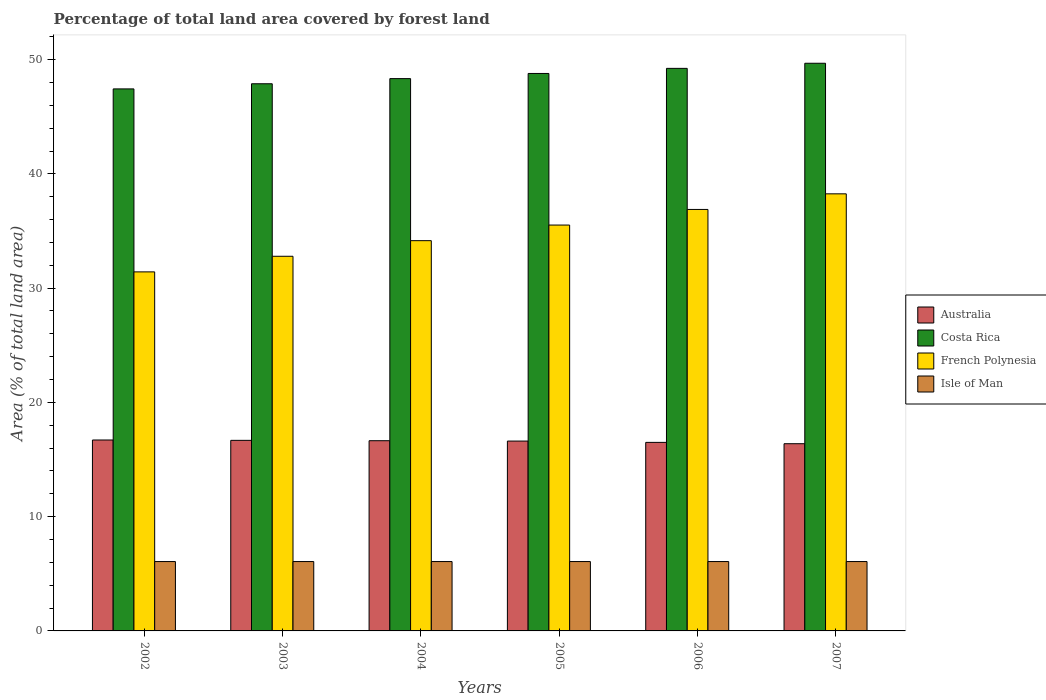How many different coloured bars are there?
Your response must be concise. 4. Are the number of bars on each tick of the X-axis equal?
Your answer should be very brief. Yes. How many bars are there on the 3rd tick from the left?
Provide a short and direct response. 4. How many bars are there on the 6th tick from the right?
Offer a very short reply. 4. What is the percentage of forest land in Isle of Man in 2003?
Your answer should be very brief. 6.07. Across all years, what is the maximum percentage of forest land in Australia?
Provide a succinct answer. 16.71. Across all years, what is the minimum percentage of forest land in French Polynesia?
Make the answer very short. 31.42. In which year was the percentage of forest land in Australia maximum?
Ensure brevity in your answer.  2002. In which year was the percentage of forest land in French Polynesia minimum?
Give a very brief answer. 2002. What is the total percentage of forest land in French Polynesia in the graph?
Offer a very short reply. 209.02. What is the difference between the percentage of forest land in Australia in 2003 and that in 2005?
Make the answer very short. 0.06. What is the difference between the percentage of forest land in Costa Rica in 2002 and the percentage of forest land in Australia in 2004?
Keep it short and to the point. 30.79. What is the average percentage of forest land in French Polynesia per year?
Provide a succinct answer. 34.84. In the year 2004, what is the difference between the percentage of forest land in Costa Rica and percentage of forest land in Isle of Man?
Offer a very short reply. 42.27. In how many years, is the percentage of forest land in Australia greater than 50 %?
Keep it short and to the point. 0. What is the ratio of the percentage of forest land in Costa Rica in 2004 to that in 2006?
Provide a short and direct response. 0.98. Is the percentage of forest land in Isle of Man in 2005 less than that in 2006?
Make the answer very short. No. Is the difference between the percentage of forest land in Costa Rica in 2002 and 2006 greater than the difference between the percentage of forest land in Isle of Man in 2002 and 2006?
Your answer should be compact. No. What is the difference between the highest and the second highest percentage of forest land in Isle of Man?
Give a very brief answer. 0. What is the difference between the highest and the lowest percentage of forest land in Costa Rica?
Offer a terse response. 2.24. In how many years, is the percentage of forest land in Costa Rica greater than the average percentage of forest land in Costa Rica taken over all years?
Your answer should be compact. 3. Is the sum of the percentage of forest land in French Polynesia in 2005 and 2007 greater than the maximum percentage of forest land in Isle of Man across all years?
Ensure brevity in your answer.  Yes. What does the 2nd bar from the left in 2003 represents?
Your response must be concise. Costa Rica. What does the 2nd bar from the right in 2004 represents?
Keep it short and to the point. French Polynesia. Is it the case that in every year, the sum of the percentage of forest land in French Polynesia and percentage of forest land in Costa Rica is greater than the percentage of forest land in Australia?
Offer a terse response. Yes. Where does the legend appear in the graph?
Provide a succinct answer. Center right. What is the title of the graph?
Provide a succinct answer. Percentage of total land area covered by forest land. Does "Afghanistan" appear as one of the legend labels in the graph?
Offer a terse response. No. What is the label or title of the X-axis?
Give a very brief answer. Years. What is the label or title of the Y-axis?
Provide a short and direct response. Area (% of total land area). What is the Area (% of total land area) of Australia in 2002?
Your answer should be compact. 16.71. What is the Area (% of total land area) of Costa Rica in 2002?
Keep it short and to the point. 47.43. What is the Area (% of total land area) of French Polynesia in 2002?
Your answer should be very brief. 31.42. What is the Area (% of total land area) of Isle of Man in 2002?
Your answer should be very brief. 6.07. What is the Area (% of total land area) in Australia in 2003?
Keep it short and to the point. 16.68. What is the Area (% of total land area) of Costa Rica in 2003?
Give a very brief answer. 47.88. What is the Area (% of total land area) in French Polynesia in 2003?
Keep it short and to the point. 32.79. What is the Area (% of total land area) in Isle of Man in 2003?
Make the answer very short. 6.07. What is the Area (% of total land area) of Australia in 2004?
Provide a short and direct response. 16.65. What is the Area (% of total land area) in Costa Rica in 2004?
Offer a very short reply. 48.34. What is the Area (% of total land area) of French Polynesia in 2004?
Offer a very short reply. 34.15. What is the Area (% of total land area) in Isle of Man in 2004?
Your response must be concise. 6.07. What is the Area (% of total land area) of Australia in 2005?
Your answer should be compact. 16.61. What is the Area (% of total land area) of Costa Rica in 2005?
Give a very brief answer. 48.79. What is the Area (% of total land area) in French Polynesia in 2005?
Your answer should be very brief. 35.52. What is the Area (% of total land area) in Isle of Man in 2005?
Keep it short and to the point. 6.07. What is the Area (% of total land area) of Australia in 2006?
Your response must be concise. 16.5. What is the Area (% of total land area) of Costa Rica in 2006?
Keep it short and to the point. 49.23. What is the Area (% of total land area) of French Polynesia in 2006?
Give a very brief answer. 36.89. What is the Area (% of total land area) in Isle of Man in 2006?
Provide a short and direct response. 6.07. What is the Area (% of total land area) of Australia in 2007?
Your answer should be very brief. 16.38. What is the Area (% of total land area) of Costa Rica in 2007?
Ensure brevity in your answer.  49.68. What is the Area (% of total land area) in French Polynesia in 2007?
Keep it short and to the point. 38.25. What is the Area (% of total land area) in Isle of Man in 2007?
Provide a succinct answer. 6.07. Across all years, what is the maximum Area (% of total land area) in Australia?
Your answer should be very brief. 16.71. Across all years, what is the maximum Area (% of total land area) of Costa Rica?
Your answer should be very brief. 49.68. Across all years, what is the maximum Area (% of total land area) in French Polynesia?
Provide a short and direct response. 38.25. Across all years, what is the maximum Area (% of total land area) in Isle of Man?
Offer a terse response. 6.07. Across all years, what is the minimum Area (% of total land area) of Australia?
Ensure brevity in your answer.  16.38. Across all years, what is the minimum Area (% of total land area) in Costa Rica?
Keep it short and to the point. 47.43. Across all years, what is the minimum Area (% of total land area) in French Polynesia?
Your answer should be compact. 31.42. Across all years, what is the minimum Area (% of total land area) in Isle of Man?
Offer a very short reply. 6.07. What is the total Area (% of total land area) of Australia in the graph?
Provide a succinct answer. 99.53. What is the total Area (% of total land area) of Costa Rica in the graph?
Ensure brevity in your answer.  291.35. What is the total Area (% of total land area) of French Polynesia in the graph?
Keep it short and to the point. 209.02. What is the total Area (% of total land area) of Isle of Man in the graph?
Make the answer very short. 36.42. What is the difference between the Area (% of total land area) of Australia in 2002 and that in 2003?
Provide a short and direct response. 0.03. What is the difference between the Area (% of total land area) in Costa Rica in 2002 and that in 2003?
Your answer should be compact. -0.45. What is the difference between the Area (% of total land area) of French Polynesia in 2002 and that in 2003?
Provide a succinct answer. -1.37. What is the difference between the Area (% of total land area) in Isle of Man in 2002 and that in 2003?
Offer a very short reply. 0. What is the difference between the Area (% of total land area) in Australia in 2002 and that in 2004?
Provide a short and direct response. 0.06. What is the difference between the Area (% of total land area) of Costa Rica in 2002 and that in 2004?
Your answer should be very brief. -0.9. What is the difference between the Area (% of total land area) in French Polynesia in 2002 and that in 2004?
Your answer should be compact. -2.73. What is the difference between the Area (% of total land area) of Australia in 2002 and that in 2005?
Offer a very short reply. 0.09. What is the difference between the Area (% of total land area) in Costa Rica in 2002 and that in 2005?
Your answer should be very brief. -1.35. What is the difference between the Area (% of total land area) in French Polynesia in 2002 and that in 2005?
Give a very brief answer. -4.1. What is the difference between the Area (% of total land area) of Isle of Man in 2002 and that in 2005?
Provide a short and direct response. 0. What is the difference between the Area (% of total land area) of Australia in 2002 and that in 2006?
Provide a succinct answer. 0.21. What is the difference between the Area (% of total land area) of Costa Rica in 2002 and that in 2006?
Your response must be concise. -1.8. What is the difference between the Area (% of total land area) of French Polynesia in 2002 and that in 2006?
Your response must be concise. -5.46. What is the difference between the Area (% of total land area) in Isle of Man in 2002 and that in 2006?
Keep it short and to the point. 0. What is the difference between the Area (% of total land area) of Australia in 2002 and that in 2007?
Offer a terse response. 0.32. What is the difference between the Area (% of total land area) in Costa Rica in 2002 and that in 2007?
Ensure brevity in your answer.  -2.24. What is the difference between the Area (% of total land area) in French Polynesia in 2002 and that in 2007?
Keep it short and to the point. -6.83. What is the difference between the Area (% of total land area) in Australia in 2003 and that in 2004?
Offer a very short reply. 0.03. What is the difference between the Area (% of total land area) in Costa Rica in 2003 and that in 2004?
Provide a succinct answer. -0.45. What is the difference between the Area (% of total land area) in French Polynesia in 2003 and that in 2004?
Ensure brevity in your answer.  -1.37. What is the difference between the Area (% of total land area) of Isle of Man in 2003 and that in 2004?
Provide a succinct answer. 0. What is the difference between the Area (% of total land area) of Australia in 2003 and that in 2005?
Your answer should be very brief. 0.06. What is the difference between the Area (% of total land area) in Costa Rica in 2003 and that in 2005?
Your answer should be compact. -0.9. What is the difference between the Area (% of total land area) of French Polynesia in 2003 and that in 2005?
Make the answer very short. -2.73. What is the difference between the Area (% of total land area) of Isle of Man in 2003 and that in 2005?
Make the answer very short. 0. What is the difference between the Area (% of total land area) in Australia in 2003 and that in 2006?
Offer a very short reply. 0.18. What is the difference between the Area (% of total land area) of Costa Rica in 2003 and that in 2006?
Your response must be concise. -1.35. What is the difference between the Area (% of total land area) in French Polynesia in 2003 and that in 2006?
Offer a terse response. -4.1. What is the difference between the Area (% of total land area) in Australia in 2003 and that in 2007?
Your response must be concise. 0.29. What is the difference between the Area (% of total land area) of Costa Rica in 2003 and that in 2007?
Your answer should be compact. -1.79. What is the difference between the Area (% of total land area) in French Polynesia in 2003 and that in 2007?
Provide a short and direct response. -5.46. What is the difference between the Area (% of total land area) in Australia in 2004 and that in 2005?
Provide a short and direct response. 0.03. What is the difference between the Area (% of total land area) in Costa Rica in 2004 and that in 2005?
Provide a succinct answer. -0.45. What is the difference between the Area (% of total land area) of French Polynesia in 2004 and that in 2005?
Offer a very short reply. -1.37. What is the difference between the Area (% of total land area) in Isle of Man in 2004 and that in 2005?
Make the answer very short. 0. What is the difference between the Area (% of total land area) in Australia in 2004 and that in 2006?
Provide a short and direct response. 0.15. What is the difference between the Area (% of total land area) of Costa Rica in 2004 and that in 2006?
Keep it short and to the point. -0.9. What is the difference between the Area (% of total land area) in French Polynesia in 2004 and that in 2006?
Offer a terse response. -2.73. What is the difference between the Area (% of total land area) of Isle of Man in 2004 and that in 2006?
Ensure brevity in your answer.  0. What is the difference between the Area (% of total land area) in Australia in 2004 and that in 2007?
Give a very brief answer. 0.26. What is the difference between the Area (% of total land area) of Costa Rica in 2004 and that in 2007?
Offer a terse response. -1.34. What is the difference between the Area (% of total land area) in French Polynesia in 2004 and that in 2007?
Your answer should be very brief. -4.1. What is the difference between the Area (% of total land area) of Isle of Man in 2004 and that in 2007?
Keep it short and to the point. 0. What is the difference between the Area (% of total land area) in Australia in 2005 and that in 2006?
Offer a terse response. 0.12. What is the difference between the Area (% of total land area) of Costa Rica in 2005 and that in 2006?
Provide a short and direct response. -0.45. What is the difference between the Area (% of total land area) of French Polynesia in 2005 and that in 2006?
Offer a very short reply. -1.37. What is the difference between the Area (% of total land area) in Isle of Man in 2005 and that in 2006?
Ensure brevity in your answer.  0. What is the difference between the Area (% of total land area) in Australia in 2005 and that in 2007?
Offer a very short reply. 0.23. What is the difference between the Area (% of total land area) in Costa Rica in 2005 and that in 2007?
Give a very brief answer. -0.89. What is the difference between the Area (% of total land area) in French Polynesia in 2005 and that in 2007?
Provide a short and direct response. -2.73. What is the difference between the Area (% of total land area) in Australia in 2006 and that in 2007?
Make the answer very short. 0.12. What is the difference between the Area (% of total land area) of Costa Rica in 2006 and that in 2007?
Offer a very short reply. -0.45. What is the difference between the Area (% of total land area) in French Polynesia in 2006 and that in 2007?
Your answer should be compact. -1.37. What is the difference between the Area (% of total land area) of Isle of Man in 2006 and that in 2007?
Offer a very short reply. 0. What is the difference between the Area (% of total land area) in Australia in 2002 and the Area (% of total land area) in Costa Rica in 2003?
Offer a very short reply. -31.18. What is the difference between the Area (% of total land area) of Australia in 2002 and the Area (% of total land area) of French Polynesia in 2003?
Offer a terse response. -16.08. What is the difference between the Area (% of total land area) of Australia in 2002 and the Area (% of total land area) of Isle of Man in 2003?
Provide a succinct answer. 10.64. What is the difference between the Area (% of total land area) of Costa Rica in 2002 and the Area (% of total land area) of French Polynesia in 2003?
Your response must be concise. 14.65. What is the difference between the Area (% of total land area) of Costa Rica in 2002 and the Area (% of total land area) of Isle of Man in 2003?
Provide a succinct answer. 41.36. What is the difference between the Area (% of total land area) in French Polynesia in 2002 and the Area (% of total land area) in Isle of Man in 2003?
Offer a very short reply. 25.35. What is the difference between the Area (% of total land area) of Australia in 2002 and the Area (% of total land area) of Costa Rica in 2004?
Your response must be concise. -31.63. What is the difference between the Area (% of total land area) in Australia in 2002 and the Area (% of total land area) in French Polynesia in 2004?
Make the answer very short. -17.44. What is the difference between the Area (% of total land area) of Australia in 2002 and the Area (% of total land area) of Isle of Man in 2004?
Make the answer very short. 10.64. What is the difference between the Area (% of total land area) of Costa Rica in 2002 and the Area (% of total land area) of French Polynesia in 2004?
Make the answer very short. 13.28. What is the difference between the Area (% of total land area) in Costa Rica in 2002 and the Area (% of total land area) in Isle of Man in 2004?
Your response must be concise. 41.36. What is the difference between the Area (% of total land area) of French Polynesia in 2002 and the Area (% of total land area) of Isle of Man in 2004?
Keep it short and to the point. 25.35. What is the difference between the Area (% of total land area) in Australia in 2002 and the Area (% of total land area) in Costa Rica in 2005?
Make the answer very short. -32.08. What is the difference between the Area (% of total land area) in Australia in 2002 and the Area (% of total land area) in French Polynesia in 2005?
Your response must be concise. -18.81. What is the difference between the Area (% of total land area) in Australia in 2002 and the Area (% of total land area) in Isle of Man in 2005?
Provide a succinct answer. 10.64. What is the difference between the Area (% of total land area) in Costa Rica in 2002 and the Area (% of total land area) in French Polynesia in 2005?
Offer a very short reply. 11.92. What is the difference between the Area (% of total land area) in Costa Rica in 2002 and the Area (% of total land area) in Isle of Man in 2005?
Your answer should be compact. 41.36. What is the difference between the Area (% of total land area) of French Polynesia in 2002 and the Area (% of total land area) of Isle of Man in 2005?
Offer a very short reply. 25.35. What is the difference between the Area (% of total land area) in Australia in 2002 and the Area (% of total land area) in Costa Rica in 2006?
Make the answer very short. -32.52. What is the difference between the Area (% of total land area) of Australia in 2002 and the Area (% of total land area) of French Polynesia in 2006?
Your response must be concise. -20.18. What is the difference between the Area (% of total land area) of Australia in 2002 and the Area (% of total land area) of Isle of Man in 2006?
Offer a very short reply. 10.64. What is the difference between the Area (% of total land area) in Costa Rica in 2002 and the Area (% of total land area) in French Polynesia in 2006?
Ensure brevity in your answer.  10.55. What is the difference between the Area (% of total land area) of Costa Rica in 2002 and the Area (% of total land area) of Isle of Man in 2006?
Ensure brevity in your answer.  41.36. What is the difference between the Area (% of total land area) of French Polynesia in 2002 and the Area (% of total land area) of Isle of Man in 2006?
Make the answer very short. 25.35. What is the difference between the Area (% of total land area) in Australia in 2002 and the Area (% of total land area) in Costa Rica in 2007?
Give a very brief answer. -32.97. What is the difference between the Area (% of total land area) in Australia in 2002 and the Area (% of total land area) in French Polynesia in 2007?
Give a very brief answer. -21.54. What is the difference between the Area (% of total land area) in Australia in 2002 and the Area (% of total land area) in Isle of Man in 2007?
Your answer should be very brief. 10.64. What is the difference between the Area (% of total land area) of Costa Rica in 2002 and the Area (% of total land area) of French Polynesia in 2007?
Ensure brevity in your answer.  9.18. What is the difference between the Area (% of total land area) of Costa Rica in 2002 and the Area (% of total land area) of Isle of Man in 2007?
Your answer should be very brief. 41.36. What is the difference between the Area (% of total land area) of French Polynesia in 2002 and the Area (% of total land area) of Isle of Man in 2007?
Give a very brief answer. 25.35. What is the difference between the Area (% of total land area) in Australia in 2003 and the Area (% of total land area) in Costa Rica in 2004?
Your response must be concise. -31.66. What is the difference between the Area (% of total land area) in Australia in 2003 and the Area (% of total land area) in French Polynesia in 2004?
Offer a very short reply. -17.48. What is the difference between the Area (% of total land area) of Australia in 2003 and the Area (% of total land area) of Isle of Man in 2004?
Make the answer very short. 10.61. What is the difference between the Area (% of total land area) of Costa Rica in 2003 and the Area (% of total land area) of French Polynesia in 2004?
Your response must be concise. 13.73. What is the difference between the Area (% of total land area) of Costa Rica in 2003 and the Area (% of total land area) of Isle of Man in 2004?
Offer a terse response. 41.81. What is the difference between the Area (% of total land area) of French Polynesia in 2003 and the Area (% of total land area) of Isle of Man in 2004?
Your response must be concise. 26.72. What is the difference between the Area (% of total land area) of Australia in 2003 and the Area (% of total land area) of Costa Rica in 2005?
Ensure brevity in your answer.  -32.11. What is the difference between the Area (% of total land area) of Australia in 2003 and the Area (% of total land area) of French Polynesia in 2005?
Your response must be concise. -18.84. What is the difference between the Area (% of total land area) of Australia in 2003 and the Area (% of total land area) of Isle of Man in 2005?
Keep it short and to the point. 10.61. What is the difference between the Area (% of total land area) of Costa Rica in 2003 and the Area (% of total land area) of French Polynesia in 2005?
Offer a very short reply. 12.37. What is the difference between the Area (% of total land area) of Costa Rica in 2003 and the Area (% of total land area) of Isle of Man in 2005?
Provide a succinct answer. 41.81. What is the difference between the Area (% of total land area) of French Polynesia in 2003 and the Area (% of total land area) of Isle of Man in 2005?
Offer a terse response. 26.72. What is the difference between the Area (% of total land area) of Australia in 2003 and the Area (% of total land area) of Costa Rica in 2006?
Offer a terse response. -32.55. What is the difference between the Area (% of total land area) in Australia in 2003 and the Area (% of total land area) in French Polynesia in 2006?
Offer a terse response. -20.21. What is the difference between the Area (% of total land area) of Australia in 2003 and the Area (% of total land area) of Isle of Man in 2006?
Offer a very short reply. 10.61. What is the difference between the Area (% of total land area) in Costa Rica in 2003 and the Area (% of total land area) in French Polynesia in 2006?
Offer a terse response. 11. What is the difference between the Area (% of total land area) of Costa Rica in 2003 and the Area (% of total land area) of Isle of Man in 2006?
Ensure brevity in your answer.  41.81. What is the difference between the Area (% of total land area) of French Polynesia in 2003 and the Area (% of total land area) of Isle of Man in 2006?
Your answer should be very brief. 26.72. What is the difference between the Area (% of total land area) of Australia in 2003 and the Area (% of total land area) of Costa Rica in 2007?
Your answer should be very brief. -33. What is the difference between the Area (% of total land area) in Australia in 2003 and the Area (% of total land area) in French Polynesia in 2007?
Offer a terse response. -21.57. What is the difference between the Area (% of total land area) of Australia in 2003 and the Area (% of total land area) of Isle of Man in 2007?
Offer a very short reply. 10.61. What is the difference between the Area (% of total land area) of Costa Rica in 2003 and the Area (% of total land area) of French Polynesia in 2007?
Give a very brief answer. 9.63. What is the difference between the Area (% of total land area) in Costa Rica in 2003 and the Area (% of total land area) in Isle of Man in 2007?
Ensure brevity in your answer.  41.81. What is the difference between the Area (% of total land area) of French Polynesia in 2003 and the Area (% of total land area) of Isle of Man in 2007?
Your answer should be compact. 26.72. What is the difference between the Area (% of total land area) in Australia in 2004 and the Area (% of total land area) in Costa Rica in 2005?
Keep it short and to the point. -32.14. What is the difference between the Area (% of total land area) in Australia in 2004 and the Area (% of total land area) in French Polynesia in 2005?
Your answer should be compact. -18.87. What is the difference between the Area (% of total land area) in Australia in 2004 and the Area (% of total land area) in Isle of Man in 2005?
Offer a very short reply. 10.58. What is the difference between the Area (% of total land area) in Costa Rica in 2004 and the Area (% of total land area) in French Polynesia in 2005?
Keep it short and to the point. 12.82. What is the difference between the Area (% of total land area) in Costa Rica in 2004 and the Area (% of total land area) in Isle of Man in 2005?
Provide a succinct answer. 42.27. What is the difference between the Area (% of total land area) in French Polynesia in 2004 and the Area (% of total land area) in Isle of Man in 2005?
Your answer should be very brief. 28.08. What is the difference between the Area (% of total land area) of Australia in 2004 and the Area (% of total land area) of Costa Rica in 2006?
Provide a succinct answer. -32.59. What is the difference between the Area (% of total land area) in Australia in 2004 and the Area (% of total land area) in French Polynesia in 2006?
Your response must be concise. -20.24. What is the difference between the Area (% of total land area) of Australia in 2004 and the Area (% of total land area) of Isle of Man in 2006?
Ensure brevity in your answer.  10.58. What is the difference between the Area (% of total land area) of Costa Rica in 2004 and the Area (% of total land area) of French Polynesia in 2006?
Offer a very short reply. 11.45. What is the difference between the Area (% of total land area) in Costa Rica in 2004 and the Area (% of total land area) in Isle of Man in 2006?
Ensure brevity in your answer.  42.27. What is the difference between the Area (% of total land area) of French Polynesia in 2004 and the Area (% of total land area) of Isle of Man in 2006?
Provide a short and direct response. 28.08. What is the difference between the Area (% of total land area) of Australia in 2004 and the Area (% of total land area) of Costa Rica in 2007?
Make the answer very short. -33.03. What is the difference between the Area (% of total land area) in Australia in 2004 and the Area (% of total land area) in French Polynesia in 2007?
Make the answer very short. -21.61. What is the difference between the Area (% of total land area) of Australia in 2004 and the Area (% of total land area) of Isle of Man in 2007?
Provide a short and direct response. 10.58. What is the difference between the Area (% of total land area) of Costa Rica in 2004 and the Area (% of total land area) of French Polynesia in 2007?
Your answer should be compact. 10.08. What is the difference between the Area (% of total land area) of Costa Rica in 2004 and the Area (% of total land area) of Isle of Man in 2007?
Ensure brevity in your answer.  42.27. What is the difference between the Area (% of total land area) in French Polynesia in 2004 and the Area (% of total land area) in Isle of Man in 2007?
Make the answer very short. 28.08. What is the difference between the Area (% of total land area) of Australia in 2005 and the Area (% of total land area) of Costa Rica in 2006?
Your answer should be compact. -32.62. What is the difference between the Area (% of total land area) in Australia in 2005 and the Area (% of total land area) in French Polynesia in 2006?
Your answer should be compact. -20.27. What is the difference between the Area (% of total land area) of Australia in 2005 and the Area (% of total land area) of Isle of Man in 2006?
Provide a succinct answer. 10.54. What is the difference between the Area (% of total land area) in Costa Rica in 2005 and the Area (% of total land area) in French Polynesia in 2006?
Provide a succinct answer. 11.9. What is the difference between the Area (% of total land area) in Costa Rica in 2005 and the Area (% of total land area) in Isle of Man in 2006?
Provide a succinct answer. 42.72. What is the difference between the Area (% of total land area) in French Polynesia in 2005 and the Area (% of total land area) in Isle of Man in 2006?
Provide a short and direct response. 29.45. What is the difference between the Area (% of total land area) in Australia in 2005 and the Area (% of total land area) in Costa Rica in 2007?
Make the answer very short. -33.06. What is the difference between the Area (% of total land area) of Australia in 2005 and the Area (% of total land area) of French Polynesia in 2007?
Provide a short and direct response. -21.64. What is the difference between the Area (% of total land area) in Australia in 2005 and the Area (% of total land area) in Isle of Man in 2007?
Give a very brief answer. 10.54. What is the difference between the Area (% of total land area) of Costa Rica in 2005 and the Area (% of total land area) of French Polynesia in 2007?
Offer a very short reply. 10.53. What is the difference between the Area (% of total land area) of Costa Rica in 2005 and the Area (% of total land area) of Isle of Man in 2007?
Your answer should be very brief. 42.72. What is the difference between the Area (% of total land area) of French Polynesia in 2005 and the Area (% of total land area) of Isle of Man in 2007?
Your answer should be very brief. 29.45. What is the difference between the Area (% of total land area) of Australia in 2006 and the Area (% of total land area) of Costa Rica in 2007?
Provide a short and direct response. -33.18. What is the difference between the Area (% of total land area) of Australia in 2006 and the Area (% of total land area) of French Polynesia in 2007?
Give a very brief answer. -21.75. What is the difference between the Area (% of total land area) of Australia in 2006 and the Area (% of total land area) of Isle of Man in 2007?
Ensure brevity in your answer.  10.43. What is the difference between the Area (% of total land area) in Costa Rica in 2006 and the Area (% of total land area) in French Polynesia in 2007?
Your answer should be very brief. 10.98. What is the difference between the Area (% of total land area) of Costa Rica in 2006 and the Area (% of total land area) of Isle of Man in 2007?
Provide a short and direct response. 43.16. What is the difference between the Area (% of total land area) of French Polynesia in 2006 and the Area (% of total land area) of Isle of Man in 2007?
Keep it short and to the point. 30.82. What is the average Area (% of total land area) of Australia per year?
Give a very brief answer. 16.59. What is the average Area (% of total land area) of Costa Rica per year?
Your answer should be very brief. 48.56. What is the average Area (% of total land area) in French Polynesia per year?
Provide a short and direct response. 34.84. What is the average Area (% of total land area) of Isle of Man per year?
Your answer should be very brief. 6.07. In the year 2002, what is the difference between the Area (% of total land area) in Australia and Area (% of total land area) in Costa Rica?
Make the answer very short. -30.73. In the year 2002, what is the difference between the Area (% of total land area) in Australia and Area (% of total land area) in French Polynesia?
Provide a succinct answer. -14.71. In the year 2002, what is the difference between the Area (% of total land area) of Australia and Area (% of total land area) of Isle of Man?
Make the answer very short. 10.64. In the year 2002, what is the difference between the Area (% of total land area) of Costa Rica and Area (% of total land area) of French Polynesia?
Make the answer very short. 16.01. In the year 2002, what is the difference between the Area (% of total land area) of Costa Rica and Area (% of total land area) of Isle of Man?
Your answer should be very brief. 41.36. In the year 2002, what is the difference between the Area (% of total land area) of French Polynesia and Area (% of total land area) of Isle of Man?
Your response must be concise. 25.35. In the year 2003, what is the difference between the Area (% of total land area) in Australia and Area (% of total land area) in Costa Rica?
Ensure brevity in your answer.  -31.21. In the year 2003, what is the difference between the Area (% of total land area) in Australia and Area (% of total land area) in French Polynesia?
Ensure brevity in your answer.  -16.11. In the year 2003, what is the difference between the Area (% of total land area) of Australia and Area (% of total land area) of Isle of Man?
Your answer should be compact. 10.61. In the year 2003, what is the difference between the Area (% of total land area) in Costa Rica and Area (% of total land area) in French Polynesia?
Your response must be concise. 15.1. In the year 2003, what is the difference between the Area (% of total land area) of Costa Rica and Area (% of total land area) of Isle of Man?
Give a very brief answer. 41.81. In the year 2003, what is the difference between the Area (% of total land area) in French Polynesia and Area (% of total land area) in Isle of Man?
Make the answer very short. 26.72. In the year 2004, what is the difference between the Area (% of total land area) in Australia and Area (% of total land area) in Costa Rica?
Ensure brevity in your answer.  -31.69. In the year 2004, what is the difference between the Area (% of total land area) of Australia and Area (% of total land area) of French Polynesia?
Give a very brief answer. -17.51. In the year 2004, what is the difference between the Area (% of total land area) of Australia and Area (% of total land area) of Isle of Man?
Ensure brevity in your answer.  10.58. In the year 2004, what is the difference between the Area (% of total land area) in Costa Rica and Area (% of total land area) in French Polynesia?
Offer a very short reply. 14.18. In the year 2004, what is the difference between the Area (% of total land area) of Costa Rica and Area (% of total land area) of Isle of Man?
Provide a succinct answer. 42.27. In the year 2004, what is the difference between the Area (% of total land area) of French Polynesia and Area (% of total land area) of Isle of Man?
Keep it short and to the point. 28.08. In the year 2005, what is the difference between the Area (% of total land area) in Australia and Area (% of total land area) in Costa Rica?
Offer a very short reply. -32.17. In the year 2005, what is the difference between the Area (% of total land area) in Australia and Area (% of total land area) in French Polynesia?
Keep it short and to the point. -18.9. In the year 2005, what is the difference between the Area (% of total land area) in Australia and Area (% of total land area) in Isle of Man?
Your answer should be very brief. 10.54. In the year 2005, what is the difference between the Area (% of total land area) of Costa Rica and Area (% of total land area) of French Polynesia?
Your answer should be very brief. 13.27. In the year 2005, what is the difference between the Area (% of total land area) of Costa Rica and Area (% of total land area) of Isle of Man?
Offer a terse response. 42.72. In the year 2005, what is the difference between the Area (% of total land area) of French Polynesia and Area (% of total land area) of Isle of Man?
Offer a terse response. 29.45. In the year 2006, what is the difference between the Area (% of total land area) of Australia and Area (% of total land area) of Costa Rica?
Make the answer very short. -32.73. In the year 2006, what is the difference between the Area (% of total land area) of Australia and Area (% of total land area) of French Polynesia?
Make the answer very short. -20.39. In the year 2006, what is the difference between the Area (% of total land area) in Australia and Area (% of total land area) in Isle of Man?
Your answer should be very brief. 10.43. In the year 2006, what is the difference between the Area (% of total land area) in Costa Rica and Area (% of total land area) in French Polynesia?
Make the answer very short. 12.35. In the year 2006, what is the difference between the Area (% of total land area) in Costa Rica and Area (% of total land area) in Isle of Man?
Your answer should be very brief. 43.16. In the year 2006, what is the difference between the Area (% of total land area) of French Polynesia and Area (% of total land area) of Isle of Man?
Offer a terse response. 30.82. In the year 2007, what is the difference between the Area (% of total land area) of Australia and Area (% of total land area) of Costa Rica?
Provide a short and direct response. -33.29. In the year 2007, what is the difference between the Area (% of total land area) in Australia and Area (% of total land area) in French Polynesia?
Your answer should be very brief. -21.87. In the year 2007, what is the difference between the Area (% of total land area) in Australia and Area (% of total land area) in Isle of Man?
Your answer should be compact. 10.31. In the year 2007, what is the difference between the Area (% of total land area) of Costa Rica and Area (% of total land area) of French Polynesia?
Provide a short and direct response. 11.43. In the year 2007, what is the difference between the Area (% of total land area) in Costa Rica and Area (% of total land area) in Isle of Man?
Your answer should be compact. 43.61. In the year 2007, what is the difference between the Area (% of total land area) of French Polynesia and Area (% of total land area) of Isle of Man?
Keep it short and to the point. 32.18. What is the ratio of the Area (% of total land area) of Costa Rica in 2002 to that in 2003?
Offer a very short reply. 0.99. What is the ratio of the Area (% of total land area) of French Polynesia in 2002 to that in 2003?
Give a very brief answer. 0.96. What is the ratio of the Area (% of total land area) of Isle of Man in 2002 to that in 2003?
Your answer should be very brief. 1. What is the ratio of the Area (% of total land area) of Australia in 2002 to that in 2004?
Give a very brief answer. 1. What is the ratio of the Area (% of total land area) in Costa Rica in 2002 to that in 2004?
Provide a succinct answer. 0.98. What is the ratio of the Area (% of total land area) in French Polynesia in 2002 to that in 2004?
Ensure brevity in your answer.  0.92. What is the ratio of the Area (% of total land area) of Australia in 2002 to that in 2005?
Your response must be concise. 1.01. What is the ratio of the Area (% of total land area) of Costa Rica in 2002 to that in 2005?
Keep it short and to the point. 0.97. What is the ratio of the Area (% of total land area) in French Polynesia in 2002 to that in 2005?
Offer a very short reply. 0.88. What is the ratio of the Area (% of total land area) of Australia in 2002 to that in 2006?
Offer a terse response. 1.01. What is the ratio of the Area (% of total land area) in Costa Rica in 2002 to that in 2006?
Give a very brief answer. 0.96. What is the ratio of the Area (% of total land area) in French Polynesia in 2002 to that in 2006?
Your answer should be very brief. 0.85. What is the ratio of the Area (% of total land area) in Australia in 2002 to that in 2007?
Make the answer very short. 1.02. What is the ratio of the Area (% of total land area) in Costa Rica in 2002 to that in 2007?
Your answer should be very brief. 0.95. What is the ratio of the Area (% of total land area) in French Polynesia in 2002 to that in 2007?
Provide a short and direct response. 0.82. What is the ratio of the Area (% of total land area) in Australia in 2003 to that in 2004?
Make the answer very short. 1. What is the ratio of the Area (% of total land area) of Costa Rica in 2003 to that in 2004?
Give a very brief answer. 0.99. What is the ratio of the Area (% of total land area) of French Polynesia in 2003 to that in 2004?
Your answer should be compact. 0.96. What is the ratio of the Area (% of total land area) in Costa Rica in 2003 to that in 2005?
Your answer should be compact. 0.98. What is the ratio of the Area (% of total land area) of Isle of Man in 2003 to that in 2005?
Provide a succinct answer. 1. What is the ratio of the Area (% of total land area) of Australia in 2003 to that in 2006?
Provide a succinct answer. 1.01. What is the ratio of the Area (% of total land area) of Costa Rica in 2003 to that in 2006?
Keep it short and to the point. 0.97. What is the ratio of the Area (% of total land area) of French Polynesia in 2003 to that in 2006?
Ensure brevity in your answer.  0.89. What is the ratio of the Area (% of total land area) of Isle of Man in 2003 to that in 2006?
Offer a very short reply. 1. What is the ratio of the Area (% of total land area) in Australia in 2003 to that in 2007?
Your answer should be very brief. 1.02. What is the ratio of the Area (% of total land area) in Costa Rica in 2003 to that in 2007?
Your answer should be very brief. 0.96. What is the ratio of the Area (% of total land area) of French Polynesia in 2003 to that in 2007?
Ensure brevity in your answer.  0.86. What is the ratio of the Area (% of total land area) in Costa Rica in 2004 to that in 2005?
Your response must be concise. 0.99. What is the ratio of the Area (% of total land area) of French Polynesia in 2004 to that in 2005?
Offer a terse response. 0.96. What is the ratio of the Area (% of total land area) in Isle of Man in 2004 to that in 2005?
Keep it short and to the point. 1. What is the ratio of the Area (% of total land area) in Australia in 2004 to that in 2006?
Provide a short and direct response. 1.01. What is the ratio of the Area (% of total land area) of Costa Rica in 2004 to that in 2006?
Your response must be concise. 0.98. What is the ratio of the Area (% of total land area) in French Polynesia in 2004 to that in 2006?
Your answer should be very brief. 0.93. What is the ratio of the Area (% of total land area) of Isle of Man in 2004 to that in 2006?
Make the answer very short. 1. What is the ratio of the Area (% of total land area) of Costa Rica in 2004 to that in 2007?
Provide a short and direct response. 0.97. What is the ratio of the Area (% of total land area) of French Polynesia in 2004 to that in 2007?
Provide a short and direct response. 0.89. What is the ratio of the Area (% of total land area) in Isle of Man in 2004 to that in 2007?
Offer a terse response. 1. What is the ratio of the Area (% of total land area) in Costa Rica in 2005 to that in 2006?
Provide a succinct answer. 0.99. What is the ratio of the Area (% of total land area) of French Polynesia in 2005 to that in 2006?
Offer a terse response. 0.96. What is the ratio of the Area (% of total land area) in Isle of Man in 2005 to that in 2006?
Keep it short and to the point. 1. What is the ratio of the Area (% of total land area) of Australia in 2005 to that in 2007?
Offer a terse response. 1.01. What is the ratio of the Area (% of total land area) of Isle of Man in 2005 to that in 2007?
Ensure brevity in your answer.  1. What is the ratio of the Area (% of total land area) of Australia in 2006 to that in 2007?
Your response must be concise. 1.01. What is the ratio of the Area (% of total land area) in Costa Rica in 2006 to that in 2007?
Your response must be concise. 0.99. What is the ratio of the Area (% of total land area) in French Polynesia in 2006 to that in 2007?
Make the answer very short. 0.96. What is the ratio of the Area (% of total land area) of Isle of Man in 2006 to that in 2007?
Make the answer very short. 1. What is the difference between the highest and the second highest Area (% of total land area) in Australia?
Provide a succinct answer. 0.03. What is the difference between the highest and the second highest Area (% of total land area) of Costa Rica?
Your answer should be very brief. 0.45. What is the difference between the highest and the second highest Area (% of total land area) in French Polynesia?
Offer a very short reply. 1.37. What is the difference between the highest and the second highest Area (% of total land area) of Isle of Man?
Your answer should be compact. 0. What is the difference between the highest and the lowest Area (% of total land area) of Australia?
Offer a very short reply. 0.32. What is the difference between the highest and the lowest Area (% of total land area) in Costa Rica?
Offer a terse response. 2.24. What is the difference between the highest and the lowest Area (% of total land area) in French Polynesia?
Offer a very short reply. 6.83. 